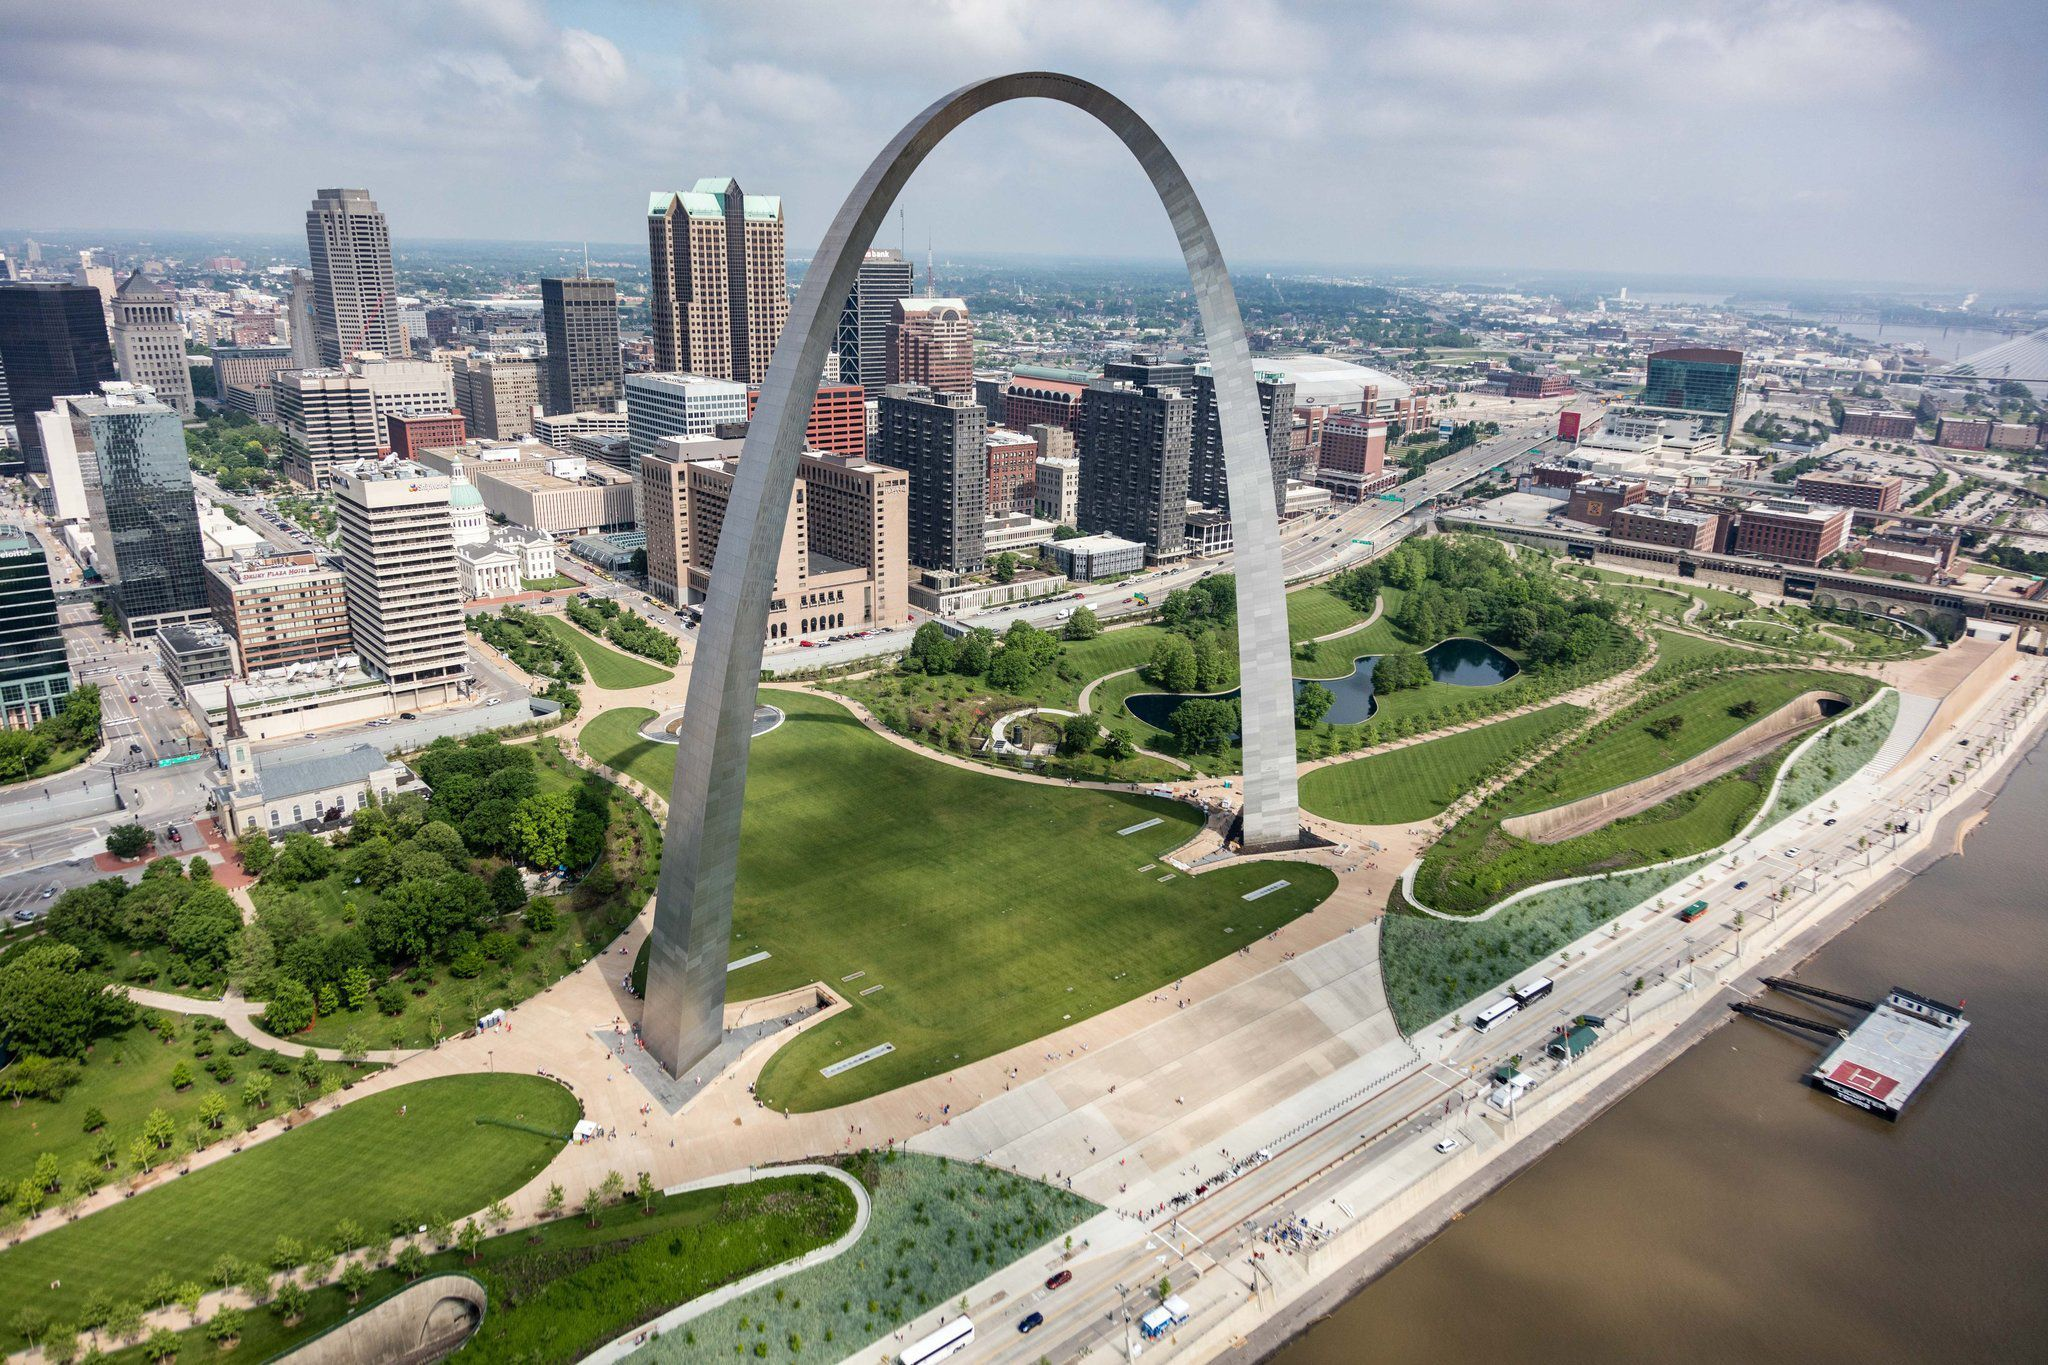Can you describe the significance of the Gateway Arch and its impact on the city's identity? The Gateway Arch stands as a symbolic gateway to the west, commemorating the westward expansion of the United States. Constructed between 1963 and 1965, this 630-foot monument has become an integral part of St. Louis's identity. It celebrates the pioneering spirit and serves as a reminder of the city's historical role as a starting point for explorations and migrations westward. The Gateway Arch's impact on the city's identity is profound: it draws millions of visitors each year, bolstering tourism and the local economy. Furthermore, its towering silhouette is a defining feature of the St. Louis skyline, embodying both the city's rich past and its forward-looking aspirations. 